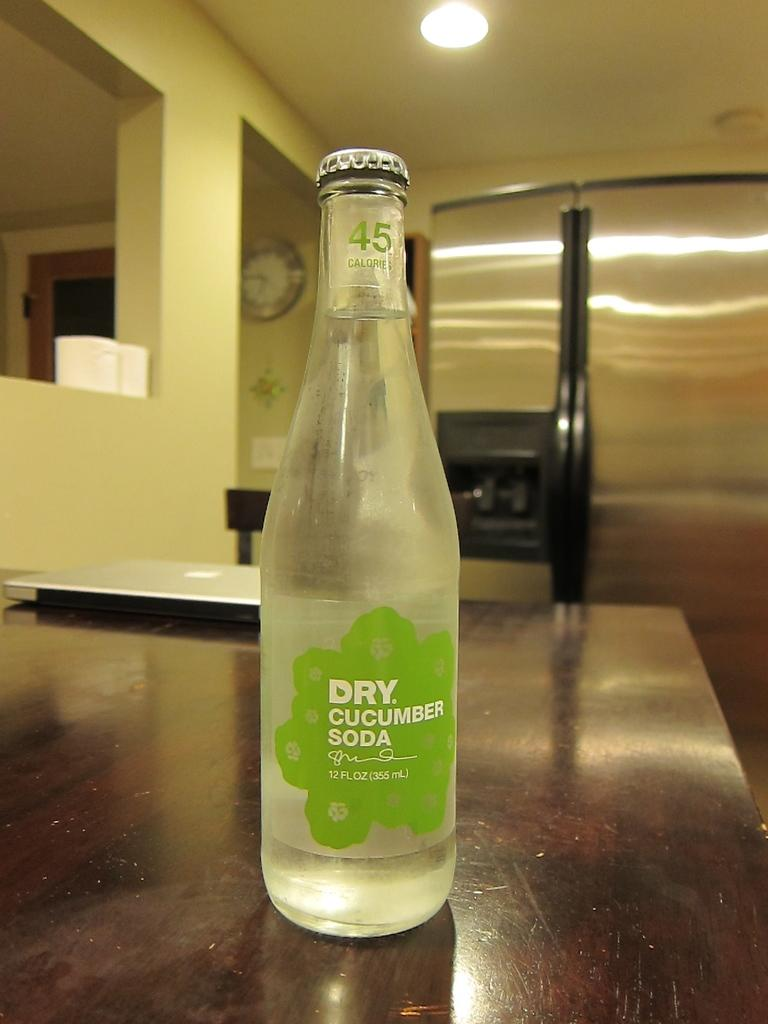<image>
Give a short and clear explanation of the subsequent image. A bottle of Dry Cucumber soda is on a desk by itself. 